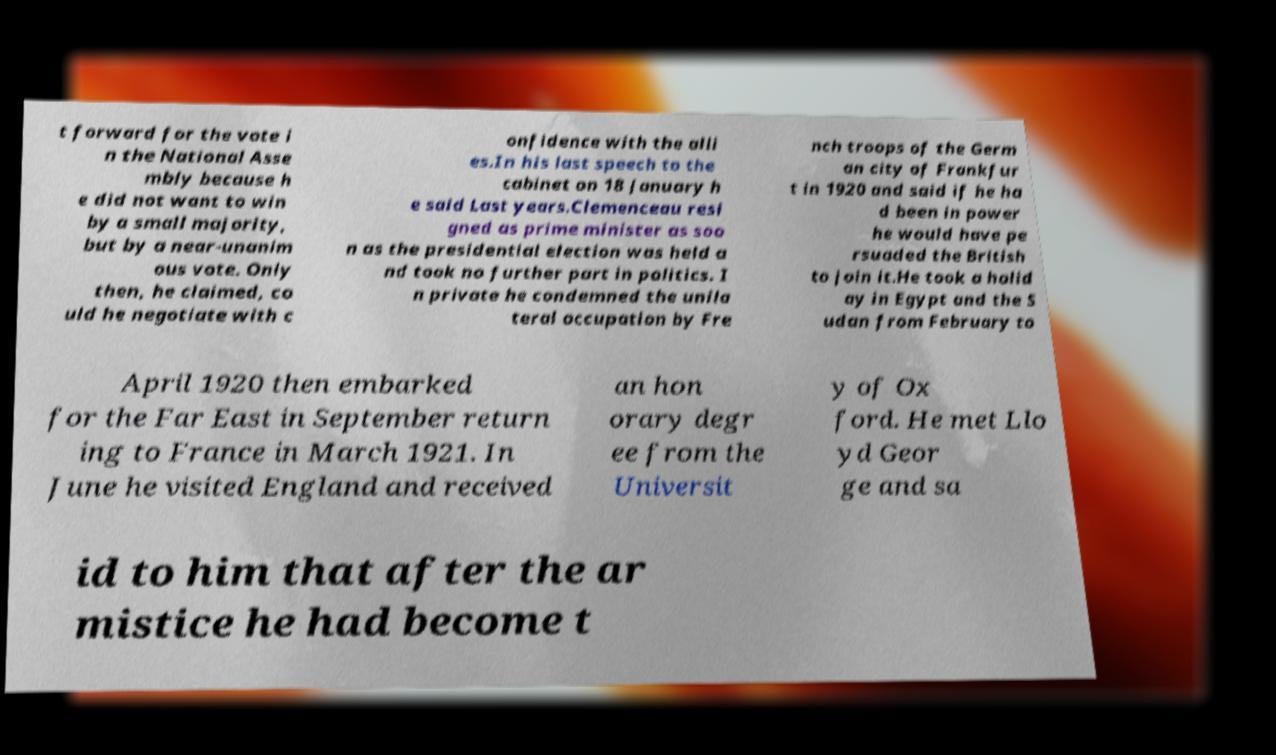I need the written content from this picture converted into text. Can you do that? t forward for the vote i n the National Asse mbly because h e did not want to win by a small majority, but by a near-unanim ous vote. Only then, he claimed, co uld he negotiate with c onfidence with the alli es.In his last speech to the cabinet on 18 January h e said Last years.Clemenceau resi gned as prime minister as soo n as the presidential election was held a nd took no further part in politics. I n private he condemned the unila teral occupation by Fre nch troops of the Germ an city of Frankfur t in 1920 and said if he ha d been in power he would have pe rsuaded the British to join it.He took a holid ay in Egypt and the S udan from February to April 1920 then embarked for the Far East in September return ing to France in March 1921. In June he visited England and received an hon orary degr ee from the Universit y of Ox ford. He met Llo yd Geor ge and sa id to him that after the ar mistice he had become t 